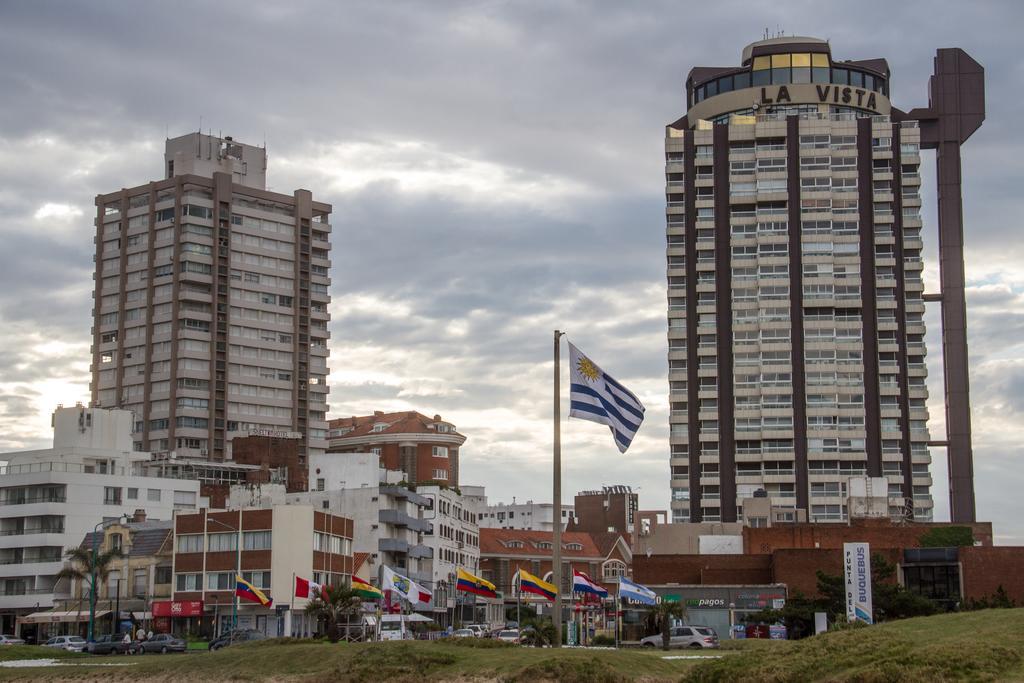Can you describe this image briefly? In this image, there are some buildings, there are some homes, there are some flags on the ground, there are some cars on the road, at the top there is a sky which is cloudy. 